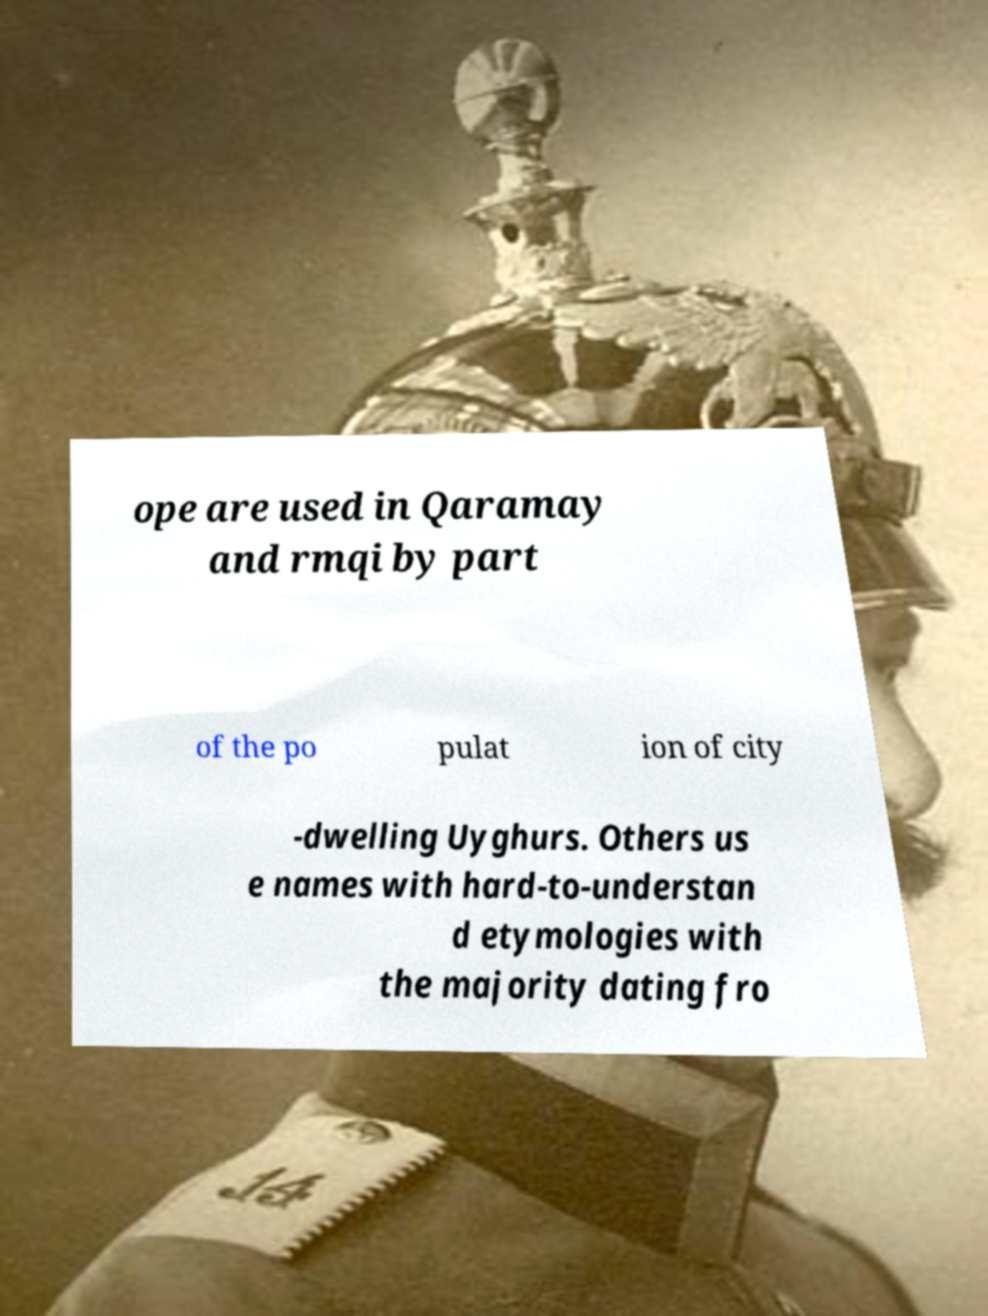Can you read and provide the text displayed in the image?This photo seems to have some interesting text. Can you extract and type it out for me? ope are used in Qaramay and rmqi by part of the po pulat ion of city -dwelling Uyghurs. Others us e names with hard-to-understan d etymologies with the majority dating fro 